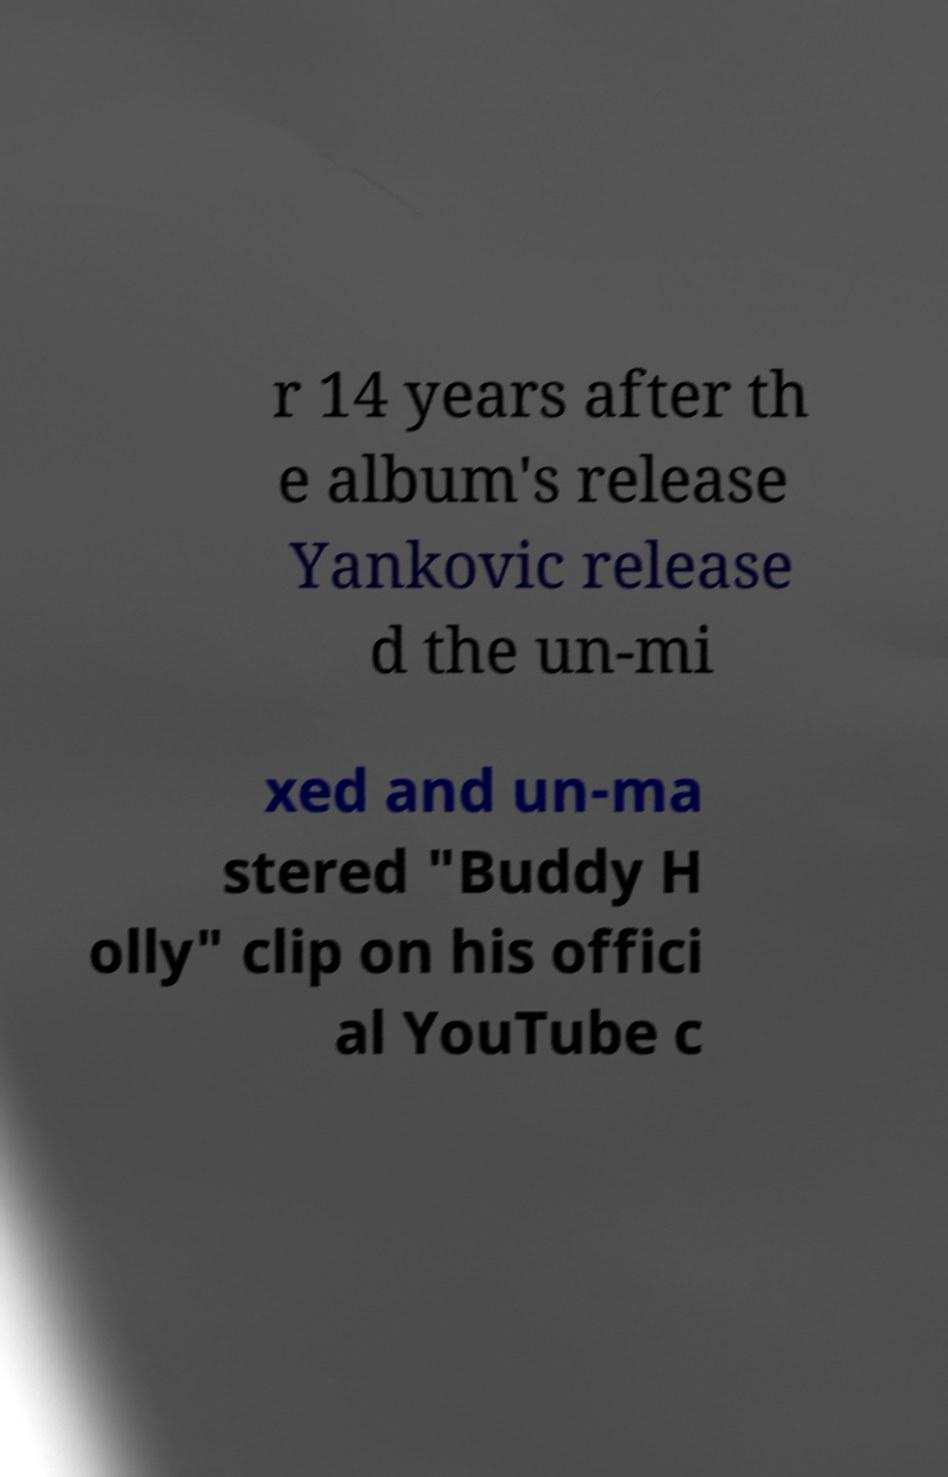I need the written content from this picture converted into text. Can you do that? r 14 years after th e album's release Yankovic release d the un-mi xed and un-ma stered "Buddy H olly" clip on his offici al YouTube c 